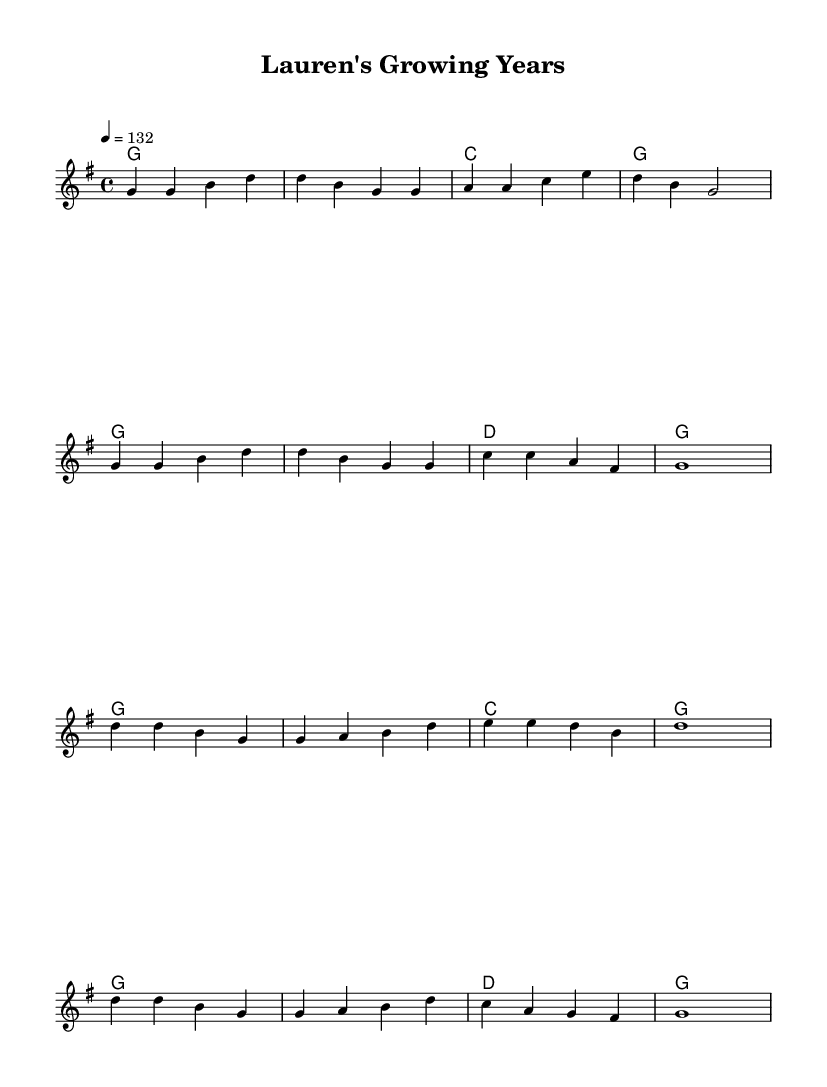What is the key signature of this music? The key signature is G major, which has one sharp (F#). This can be determined by the global settings in the score, where it states `\key g \major`.
Answer: G major What is the time signature of this music? The time signature is 4/4, as indicated by `\time 4/4` in the global settings. This means there are four beats per measure, and each quarter note gets one beat.
Answer: 4/4 What is the tempo marking of this piece? The tempo marking is 132 beats per minute, as indicated by `\tempo 4 = 132` in the global section, specifying how fast the music should be played.
Answer: 132 What is the first note of the melody? The first note of the melody is G. Looking at the melody section, the first note is represented as `g4`, which means it's a G note played for one quarter note duration.
Answer: G How many measures are in the verse of the music? There are 8 measures in the verse section. By analyzing the melody and harmonies, we can see that the verse is repeated twice, with a total of 4 measures each time. Therefore, overall it consists of 8 measures.
Answer: 8 What is the primary theme of the song? The primary theme revolves around watching children grow up. This can be inferred from the title "Lauren's Growing Years," suggesting a focus on the experiences and emotions tied to childhood and parenthood, which is common in country rock music.
Answer: Watching children grow up What chords are used in the chorus? The chords used in the chorus are G, C, and D. Analyzing the harmonies during the chorus shows that only these three chords are present throughout the chorus section, reflecting a common pattern in country rock songs.
Answer: G, C, and D 